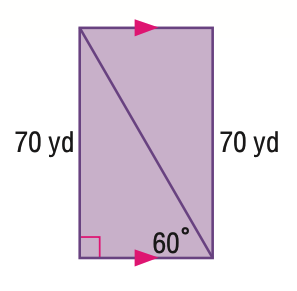Answer the mathemtical geometry problem and directly provide the correct option letter.
Question: Find the area of the quadrilateral.
Choices: A: 2450 B: 2829.0 C: 3464.8 D: 4900 B 